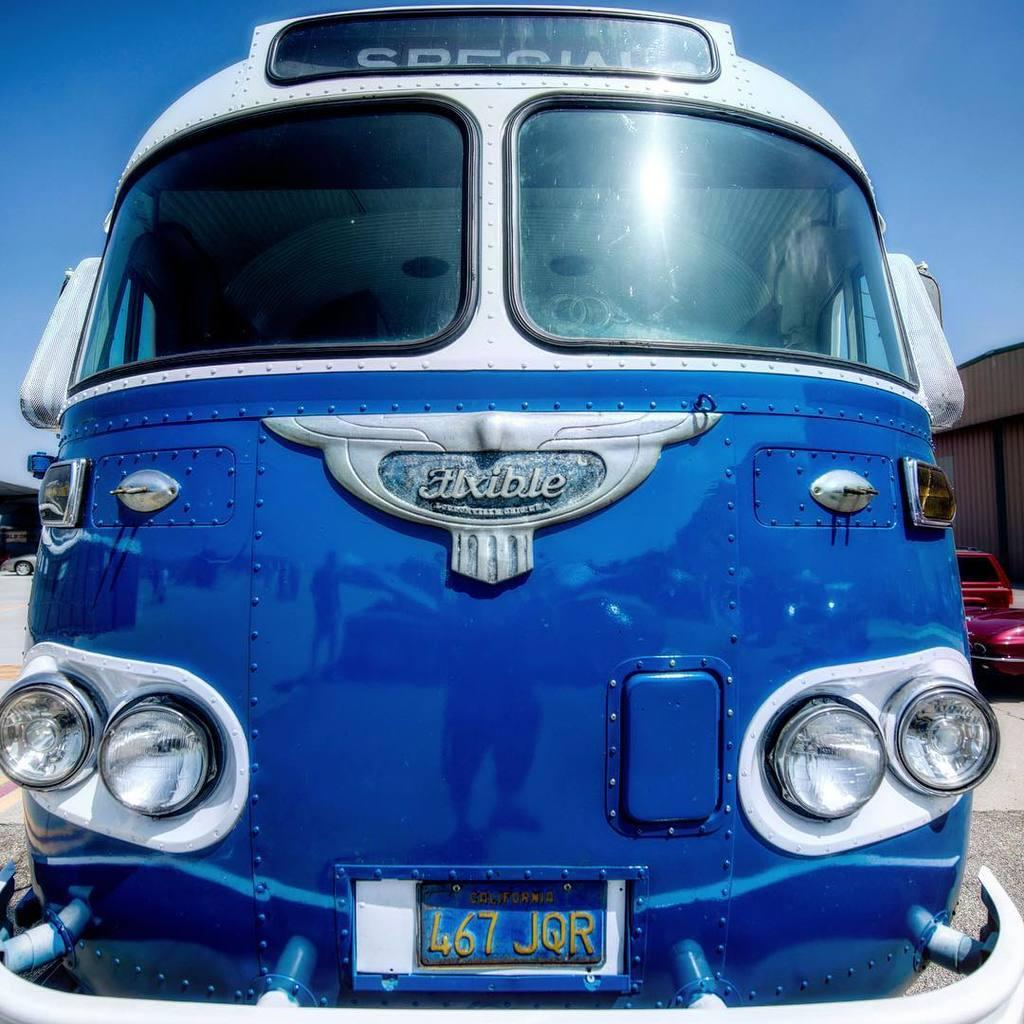What is the main subject of the image? The main subject of the image is a vehicle. What can be seen on the vehicle? The vehicle has a number plate and lights. What is visible in the background of the image? The sky is visible in the background of the image. What type of sofa can be seen in the image? There is no sofa present in the image; it features a vehicle. What group of people might be associated with the drug mentioned in the image? There is no mention of a drug or any group of people in the image. 